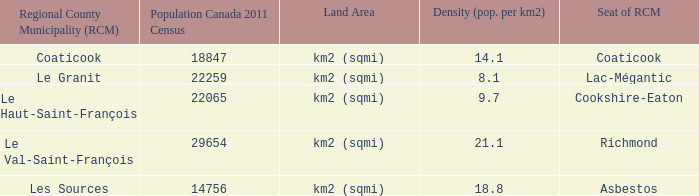What rcm can be found with a 9.7 density? Le Haut-Saint-François. Can you parse all the data within this table? {'header': ['Regional County Municipality (RCM)', 'Population Canada 2011 Census', 'Land Area', 'Density (pop. per km2)', 'Seat of RCM'], 'rows': [['Coaticook', '18847', 'km2 (sqmi)', '14.1', 'Coaticook'], ['Le Granit', '22259', 'km2 (sqmi)', '8.1', 'Lac-Mégantic'], ['Le Haut-Saint-François', '22065', 'km2 (sqmi)', '9.7', 'Cookshire-Eaton'], ['Le Val-Saint-François', '29654', 'km2 (sqmi)', '21.1', 'Richmond'], ['Les Sources', '14756', 'km2 (sqmi)', '18.8', 'Asbestos']]} 